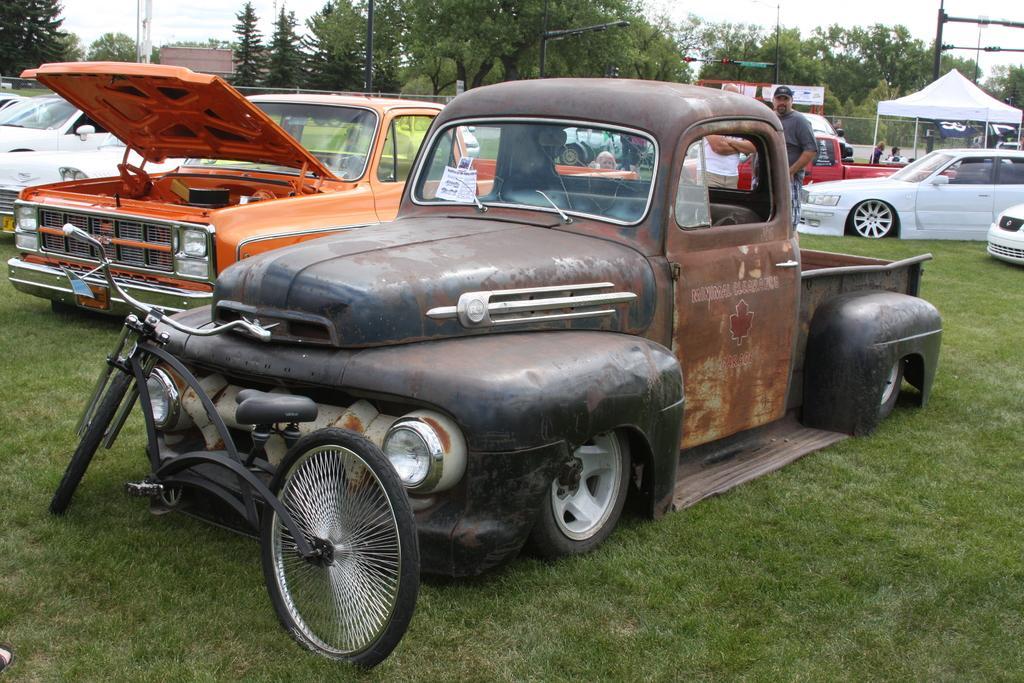How would you summarize this image in a sentence or two? In this image we can see a few vehicles on the ground, there are some trees, people, poles, grass, fence and a tent, in the background we can see a building and the sky. 